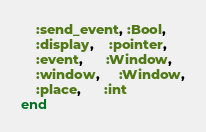Convert code to text. <code><loc_0><loc_0><loc_500><loc_500><_Ruby_>    :send_event, :Bool,
    :display,    :pointer,
    :event,      :Window,
    :window,     :Window,
    :place,      :int
end
</code> 